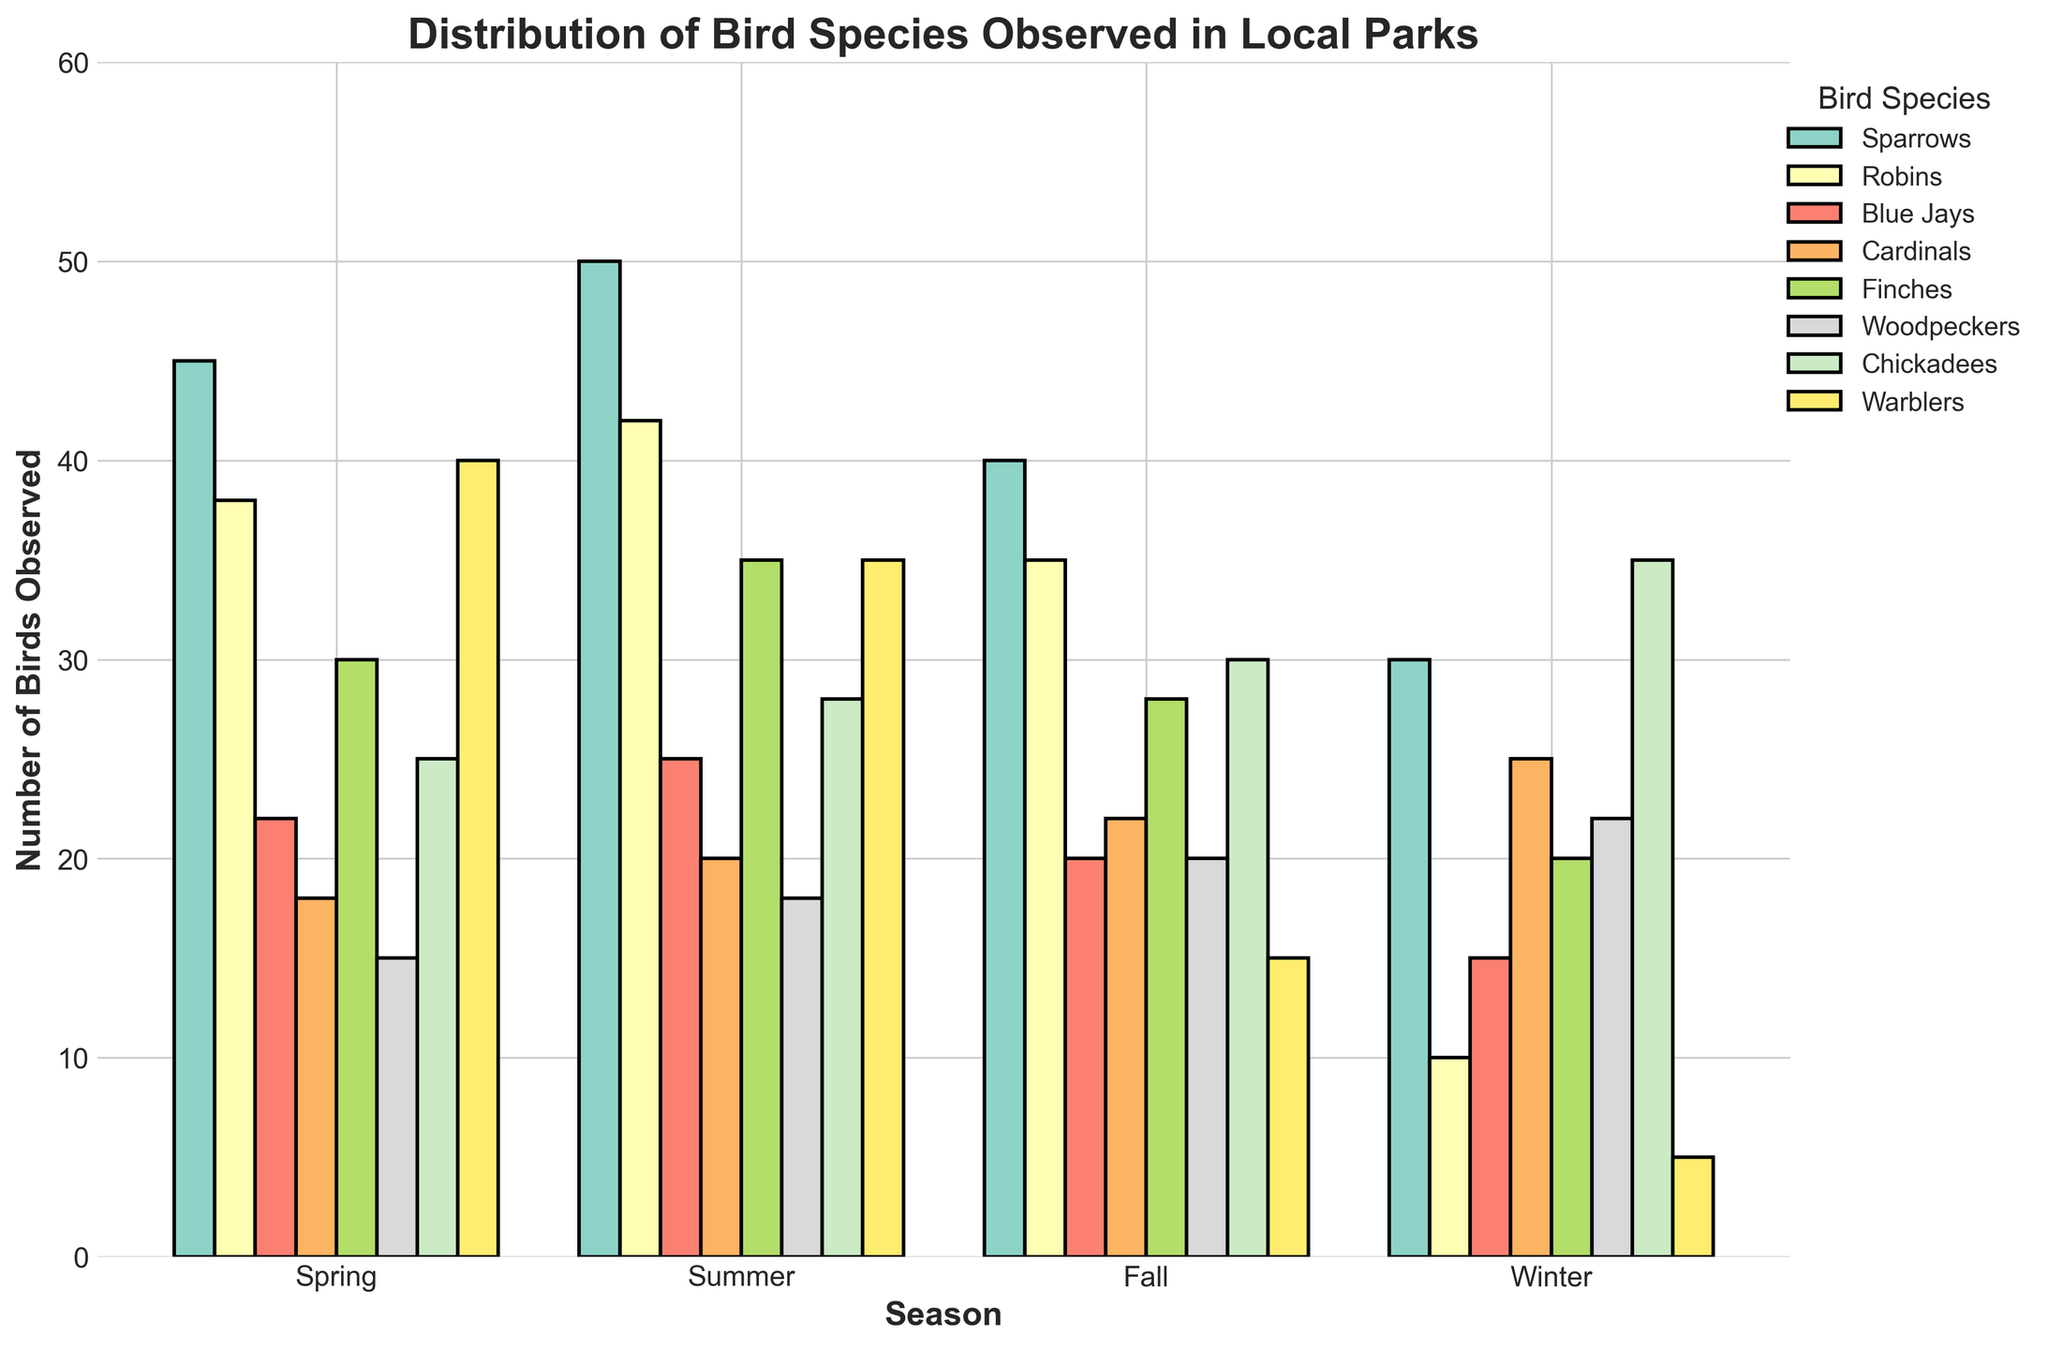Which season has the highest number of Woodpeckers observed? By examining each season's bar for Woodpeckers in the figure, we see the highest bar is for Winter, indicating that Winter has the most Woodpeckers observed.
Answer: Winter How many total Sparrows were observed across all seasons? The number of Sparrows observed in each season is given as 45 in Spring, 50 in Summer, 40 in Fall, and 30 in Winter. Adding these values together gives 45 + 50 + 40 + 30 = 165.
Answer: 165 Which season has the lowest number of Warblers observed? Looking at the bars representing Warblers in each season, Winter has the smallest bar for Warblers which is 5.
Answer: Winter Compare the number of Finches observed in Spring and Fall. Which season had more Finches? By comparing the heights of the bars for Finches in Spring (30) and Fall (28), Spring has a taller bar which means more Finches were observed in Spring.
Answer: Spring What is the average number of Blue Jays observed per season? The number of Blue Jays observed in each season is 22 (Spring), 25 (Summer), 20 (Fall), and 15 (Winter). Adding these together gives 22 + 25 + 20 + 15 = 82, and dividing by 4 (the number of seasons) gives 82 / 4 = 20.5
Answer: 20.5 Which bird species had the highest number of observations in Summer? By looking at the bars for each bird species in Summer, the tallest bar is for Sparrows (50).
Answer: Sparrows How many more Cardinals were observed in Winter than in Fall? The number of Cardinals observed in Winter is 25, and in Fall is 22. The difference is 25 - 22 = 3.
Answer: 3 What's the total number of birds observed in Fall? Adding the number of all species observed in Fall: 40 (Sparrows) + 35 (Robins) + 20 (Blue Jays) + 22 (Cardinals) + 28 (Finches) + 20 (Woodpeckers) + 30 (Chickadees) + 15 (Warblers) = 210.
Answer: 210 